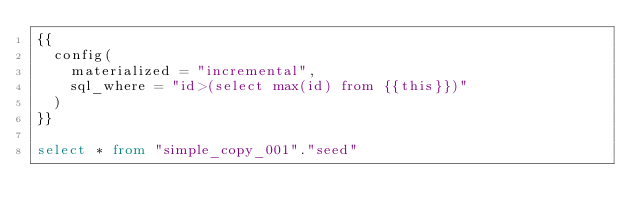<code> <loc_0><loc_0><loc_500><loc_500><_SQL_>{{
  config(
    materialized = "incremental",
    sql_where = "id>(select max(id) from {{this}})"
  )
}}

select * from "simple_copy_001"."seed"
</code> 